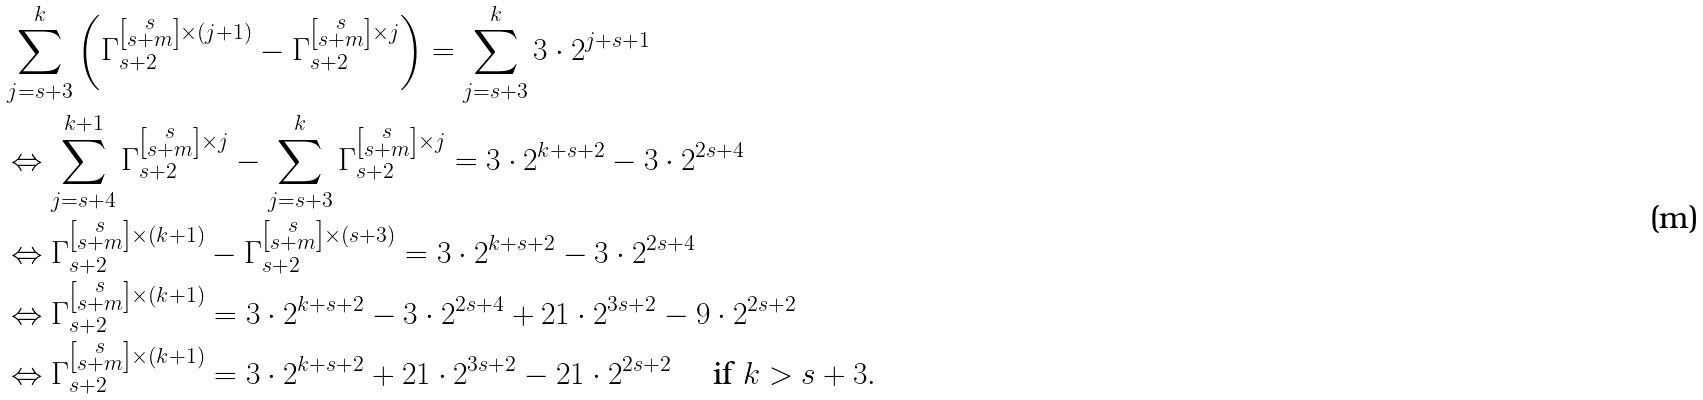Convert formula to latex. <formula><loc_0><loc_0><loc_500><loc_500>& \sum _ { j = s + 3 } ^ { k } \left ( \Gamma _ { s + 2 } ^ { \left [ \substack { s \\ s + m } \right ] \times ( j + 1 ) } - \Gamma _ { s + 2 } ^ { \left [ \substack { s \\ s + m } \right ] \times j } \right ) = \sum _ { j = s + 3 } ^ { k } 3 \cdot 2 ^ { j + s + 1 } \\ & \Leftrightarrow \sum _ { j = s + 4 } ^ { k + 1 } \Gamma _ { s + 2 } ^ { \left [ \substack { s \\ s + m } \right ] \times j } - \sum _ { j = s + 3 } ^ { k } \Gamma _ { s + 2 } ^ { \left [ \substack { s \\ s + m } \right ] \times j } = 3 \cdot 2 ^ { k + s + 2 } - 3 \cdot 2 ^ { 2 s + 4 } \\ & \Leftrightarrow \Gamma _ { s + 2 } ^ { \left [ \substack { s \\ s + m } \right ] \times ( k + 1 ) } - \Gamma _ { s + 2 } ^ { \left [ \substack { s \\ s + m } \right ] \times ( s + 3 ) } = 3 \cdot 2 ^ { k + s + 2 } - 3 \cdot 2 ^ { 2 s + 4 } \\ & \Leftrightarrow \Gamma _ { s + 2 } ^ { \left [ \substack { s \\ s + m } \right ] \times ( k + 1 ) } = 3 \cdot 2 ^ { k + s + 2 } - 3 \cdot 2 ^ { 2 s + 4 } + 2 1 \cdot 2 ^ { 3 s + 2 } - 9 \cdot 2 ^ { 2 s + 2 } \\ & \Leftrightarrow \Gamma _ { s + 2 } ^ { \left [ \substack { s \\ s + m } \right ] \times ( k + 1 ) } = 3 \cdot 2 ^ { k + s + 2 } + 2 1 \cdot 2 ^ { 3 s + 2 } - 2 1 \cdot 2 ^ { 2 s + 2 } \quad \text { if $ k > s+ 3 $} . \\ &</formula> 